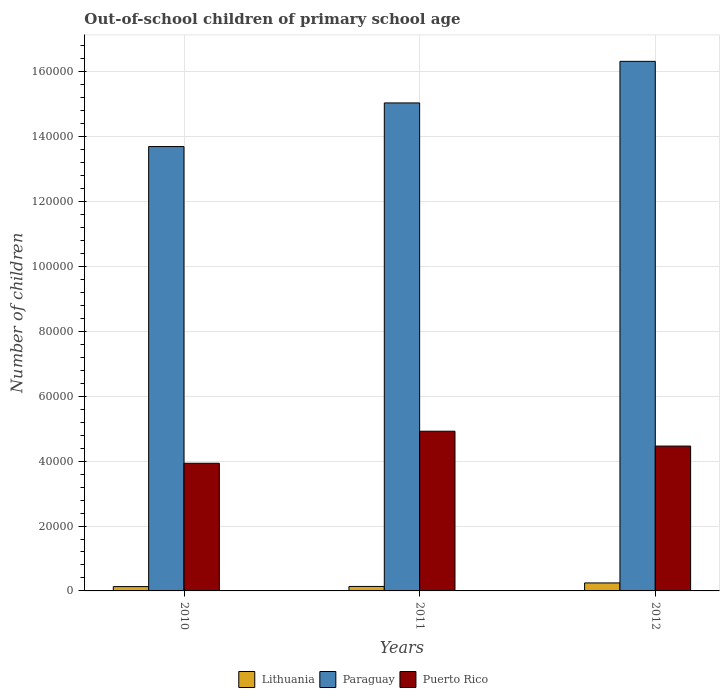How many different coloured bars are there?
Make the answer very short. 3. Are the number of bars on each tick of the X-axis equal?
Ensure brevity in your answer.  Yes. How many bars are there on the 2nd tick from the left?
Your response must be concise. 3. How many bars are there on the 3rd tick from the right?
Offer a terse response. 3. What is the label of the 3rd group of bars from the left?
Ensure brevity in your answer.  2012. What is the number of out-of-school children in Paraguay in 2012?
Provide a succinct answer. 1.63e+05. Across all years, what is the maximum number of out-of-school children in Lithuania?
Your answer should be compact. 2463. Across all years, what is the minimum number of out-of-school children in Puerto Rico?
Give a very brief answer. 3.93e+04. In which year was the number of out-of-school children in Paraguay maximum?
Provide a short and direct response. 2012. What is the total number of out-of-school children in Puerto Rico in the graph?
Offer a terse response. 1.33e+05. What is the difference between the number of out-of-school children in Puerto Rico in 2011 and that in 2012?
Offer a terse response. 4581. What is the difference between the number of out-of-school children in Puerto Rico in 2011 and the number of out-of-school children in Paraguay in 2012?
Your answer should be compact. -1.14e+05. What is the average number of out-of-school children in Lithuania per year?
Your response must be concise. 1725.67. In the year 2012, what is the difference between the number of out-of-school children in Lithuania and number of out-of-school children in Paraguay?
Your response must be concise. -1.61e+05. In how many years, is the number of out-of-school children in Paraguay greater than 16000?
Your answer should be compact. 3. What is the ratio of the number of out-of-school children in Puerto Rico in 2010 to that in 2011?
Your answer should be compact. 0.8. Is the difference between the number of out-of-school children in Lithuania in 2011 and 2012 greater than the difference between the number of out-of-school children in Paraguay in 2011 and 2012?
Your answer should be compact. Yes. What is the difference between the highest and the second highest number of out-of-school children in Puerto Rico?
Provide a short and direct response. 4581. What is the difference between the highest and the lowest number of out-of-school children in Lithuania?
Keep it short and to the point. 1130. What does the 2nd bar from the left in 2010 represents?
Your answer should be compact. Paraguay. What does the 1st bar from the right in 2011 represents?
Provide a succinct answer. Puerto Rico. Are all the bars in the graph horizontal?
Provide a short and direct response. No. How many years are there in the graph?
Offer a very short reply. 3. Are the values on the major ticks of Y-axis written in scientific E-notation?
Offer a terse response. No. What is the title of the graph?
Your answer should be very brief. Out-of-school children of primary school age. What is the label or title of the Y-axis?
Keep it short and to the point. Number of children. What is the Number of children in Lithuania in 2010?
Keep it short and to the point. 1333. What is the Number of children of Paraguay in 2010?
Your answer should be compact. 1.37e+05. What is the Number of children of Puerto Rico in 2010?
Provide a short and direct response. 3.93e+04. What is the Number of children in Lithuania in 2011?
Give a very brief answer. 1381. What is the Number of children of Paraguay in 2011?
Provide a succinct answer. 1.50e+05. What is the Number of children of Puerto Rico in 2011?
Your response must be concise. 4.92e+04. What is the Number of children in Lithuania in 2012?
Provide a succinct answer. 2463. What is the Number of children of Paraguay in 2012?
Your response must be concise. 1.63e+05. What is the Number of children in Puerto Rico in 2012?
Ensure brevity in your answer.  4.46e+04. Across all years, what is the maximum Number of children in Lithuania?
Your response must be concise. 2463. Across all years, what is the maximum Number of children of Paraguay?
Your response must be concise. 1.63e+05. Across all years, what is the maximum Number of children in Puerto Rico?
Offer a very short reply. 4.92e+04. Across all years, what is the minimum Number of children in Lithuania?
Provide a short and direct response. 1333. Across all years, what is the minimum Number of children in Paraguay?
Provide a short and direct response. 1.37e+05. Across all years, what is the minimum Number of children in Puerto Rico?
Offer a terse response. 3.93e+04. What is the total Number of children in Lithuania in the graph?
Offer a terse response. 5177. What is the total Number of children of Paraguay in the graph?
Your response must be concise. 4.51e+05. What is the total Number of children of Puerto Rico in the graph?
Offer a terse response. 1.33e+05. What is the difference between the Number of children of Lithuania in 2010 and that in 2011?
Give a very brief answer. -48. What is the difference between the Number of children in Paraguay in 2010 and that in 2011?
Offer a very short reply. -1.34e+04. What is the difference between the Number of children of Puerto Rico in 2010 and that in 2011?
Provide a succinct answer. -9877. What is the difference between the Number of children in Lithuania in 2010 and that in 2012?
Your response must be concise. -1130. What is the difference between the Number of children in Paraguay in 2010 and that in 2012?
Give a very brief answer. -2.63e+04. What is the difference between the Number of children in Puerto Rico in 2010 and that in 2012?
Offer a terse response. -5296. What is the difference between the Number of children of Lithuania in 2011 and that in 2012?
Give a very brief answer. -1082. What is the difference between the Number of children of Paraguay in 2011 and that in 2012?
Give a very brief answer. -1.28e+04. What is the difference between the Number of children of Puerto Rico in 2011 and that in 2012?
Give a very brief answer. 4581. What is the difference between the Number of children in Lithuania in 2010 and the Number of children in Paraguay in 2011?
Ensure brevity in your answer.  -1.49e+05. What is the difference between the Number of children in Lithuania in 2010 and the Number of children in Puerto Rico in 2011?
Provide a succinct answer. -4.79e+04. What is the difference between the Number of children of Paraguay in 2010 and the Number of children of Puerto Rico in 2011?
Give a very brief answer. 8.77e+04. What is the difference between the Number of children of Lithuania in 2010 and the Number of children of Paraguay in 2012?
Make the answer very short. -1.62e+05. What is the difference between the Number of children in Lithuania in 2010 and the Number of children in Puerto Rico in 2012?
Offer a very short reply. -4.33e+04. What is the difference between the Number of children of Paraguay in 2010 and the Number of children of Puerto Rico in 2012?
Give a very brief answer. 9.23e+04. What is the difference between the Number of children in Lithuania in 2011 and the Number of children in Paraguay in 2012?
Your answer should be compact. -1.62e+05. What is the difference between the Number of children in Lithuania in 2011 and the Number of children in Puerto Rico in 2012?
Your answer should be very brief. -4.33e+04. What is the difference between the Number of children in Paraguay in 2011 and the Number of children in Puerto Rico in 2012?
Offer a very short reply. 1.06e+05. What is the average Number of children of Lithuania per year?
Provide a succinct answer. 1725.67. What is the average Number of children in Paraguay per year?
Make the answer very short. 1.50e+05. What is the average Number of children in Puerto Rico per year?
Provide a short and direct response. 4.44e+04. In the year 2010, what is the difference between the Number of children in Lithuania and Number of children in Paraguay?
Give a very brief answer. -1.36e+05. In the year 2010, what is the difference between the Number of children in Lithuania and Number of children in Puerto Rico?
Your answer should be very brief. -3.80e+04. In the year 2010, what is the difference between the Number of children of Paraguay and Number of children of Puerto Rico?
Your answer should be very brief. 9.76e+04. In the year 2011, what is the difference between the Number of children in Lithuania and Number of children in Paraguay?
Your response must be concise. -1.49e+05. In the year 2011, what is the difference between the Number of children in Lithuania and Number of children in Puerto Rico?
Offer a very short reply. -4.78e+04. In the year 2011, what is the difference between the Number of children of Paraguay and Number of children of Puerto Rico?
Your answer should be very brief. 1.01e+05. In the year 2012, what is the difference between the Number of children of Lithuania and Number of children of Paraguay?
Your answer should be compact. -1.61e+05. In the year 2012, what is the difference between the Number of children of Lithuania and Number of children of Puerto Rico?
Provide a short and direct response. -4.22e+04. In the year 2012, what is the difference between the Number of children in Paraguay and Number of children in Puerto Rico?
Give a very brief answer. 1.19e+05. What is the ratio of the Number of children in Lithuania in 2010 to that in 2011?
Provide a succinct answer. 0.97. What is the ratio of the Number of children of Paraguay in 2010 to that in 2011?
Offer a very short reply. 0.91. What is the ratio of the Number of children in Puerto Rico in 2010 to that in 2011?
Provide a short and direct response. 0.8. What is the ratio of the Number of children in Lithuania in 2010 to that in 2012?
Your answer should be very brief. 0.54. What is the ratio of the Number of children of Paraguay in 2010 to that in 2012?
Provide a succinct answer. 0.84. What is the ratio of the Number of children of Puerto Rico in 2010 to that in 2012?
Provide a succinct answer. 0.88. What is the ratio of the Number of children of Lithuania in 2011 to that in 2012?
Offer a terse response. 0.56. What is the ratio of the Number of children of Paraguay in 2011 to that in 2012?
Offer a terse response. 0.92. What is the ratio of the Number of children of Puerto Rico in 2011 to that in 2012?
Give a very brief answer. 1.1. What is the difference between the highest and the second highest Number of children of Lithuania?
Give a very brief answer. 1082. What is the difference between the highest and the second highest Number of children in Paraguay?
Offer a terse response. 1.28e+04. What is the difference between the highest and the second highest Number of children of Puerto Rico?
Your response must be concise. 4581. What is the difference between the highest and the lowest Number of children in Lithuania?
Provide a succinct answer. 1130. What is the difference between the highest and the lowest Number of children in Paraguay?
Provide a short and direct response. 2.63e+04. What is the difference between the highest and the lowest Number of children of Puerto Rico?
Give a very brief answer. 9877. 